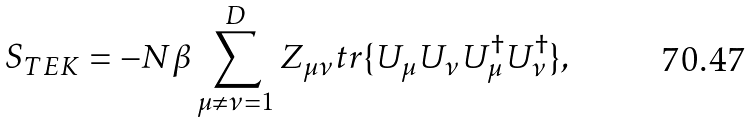Convert formula to latex. <formula><loc_0><loc_0><loc_500><loc_500>S _ { T E K } = - N \beta \sum _ { \mu \ne \nu = 1 } ^ { D } Z _ { \mu \nu } t r \{ U _ { \mu } U _ { \nu } U ^ { \dag } _ { \mu } U ^ { \dag } _ { \nu } \} ,</formula> 